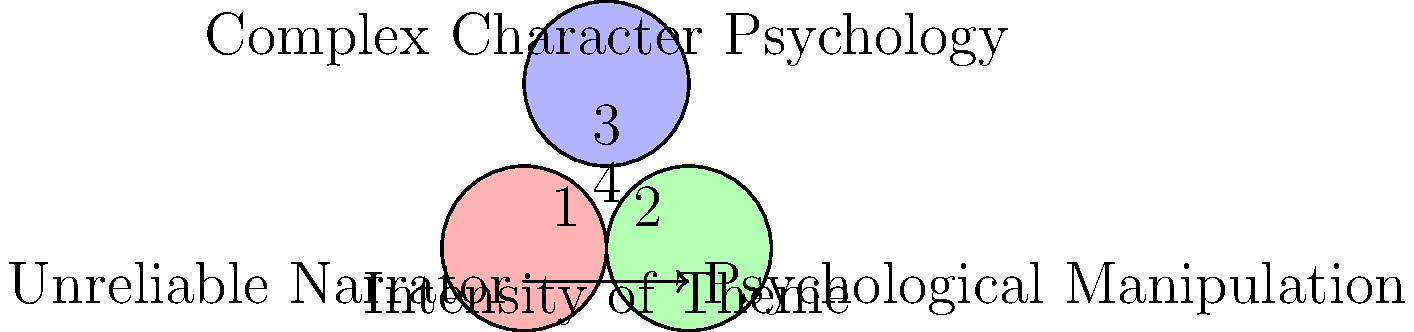Analyze the Venn diagram depicting common thematic elements in psychological thrillers. Which region (labeled 1-4) represents the intersection of all three themes: Unreliable Narrator, Psychological Manipulation, and Complex Character Psychology? How might this combination of elements contribute to the overall impact of a psychological thriller? Provide examples from notable works in the genre to support your analysis. To answer this question, let's break it down step-by-step:

1. Identify the regions:
   - Region 1: Unique to Unreliable Narrator
   - Region 2: Unique to Psychological Manipulation
   - Region 3: Unique to Complex Character Psychology
   - Region 4: Intersection of all three themes

2. The intersection of all three themes is represented by region 4, which is at the center of the Venn diagram.

3. Analysis of the combination:
   a) Unreliable Narrator: Creates doubt and uncertainty in the reader's mind.
   b) Psychological Manipulation: Involves characters influencing others' thoughts and actions.
   c) Complex Character Psychology: Delves into intricate mental states and motivations.

4. Combined impact:
   - Heightened suspense and tension
   - Increased reader engagement through multiple layers of interpretation
   - Deeper exploration of characters' psyches and motivations
   - Blurred lines between reality and perception

5. Examples from notable works:
   a) "Gone Girl" by Gillian Flynn:
      - Unreliable narrators (Amy and Nick)
      - Psychological manipulation (Amy's elaborate scheme)
      - Complex character psychology (both protagonists' intricate motivations)

   b) "The Girl on the Train" by Paula Hawkins:
      - Unreliable narrator (Rachel's alcoholism-induced memory gaps)
      - Psychological manipulation (Megan and Tom's deceptions)
      - Complex character psychology (Rachel's struggles with addiction and self-worth)

   c) "Shutter Island" by Dennis Lehane:
      - Unreliable narrator (Teddy's delusions)
      - Psychological manipulation (the entire island's setup)
      - Complex character psychology (Teddy's trauma and coping mechanisms)

These examples demonstrate how the combination of all three themes creates multi-layered, psychologically intense narratives that challenge readers' perceptions and keep them guessing until the end.
Answer: Region 4; intensifies suspense, engages readers, and creates multi-layered narratives. 